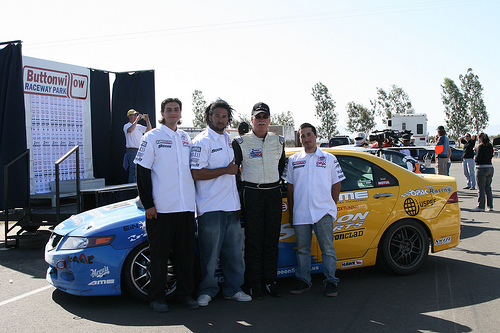<image>
Is the car in front of the man? No. The car is not in front of the man. The spatial positioning shows a different relationship between these objects. 